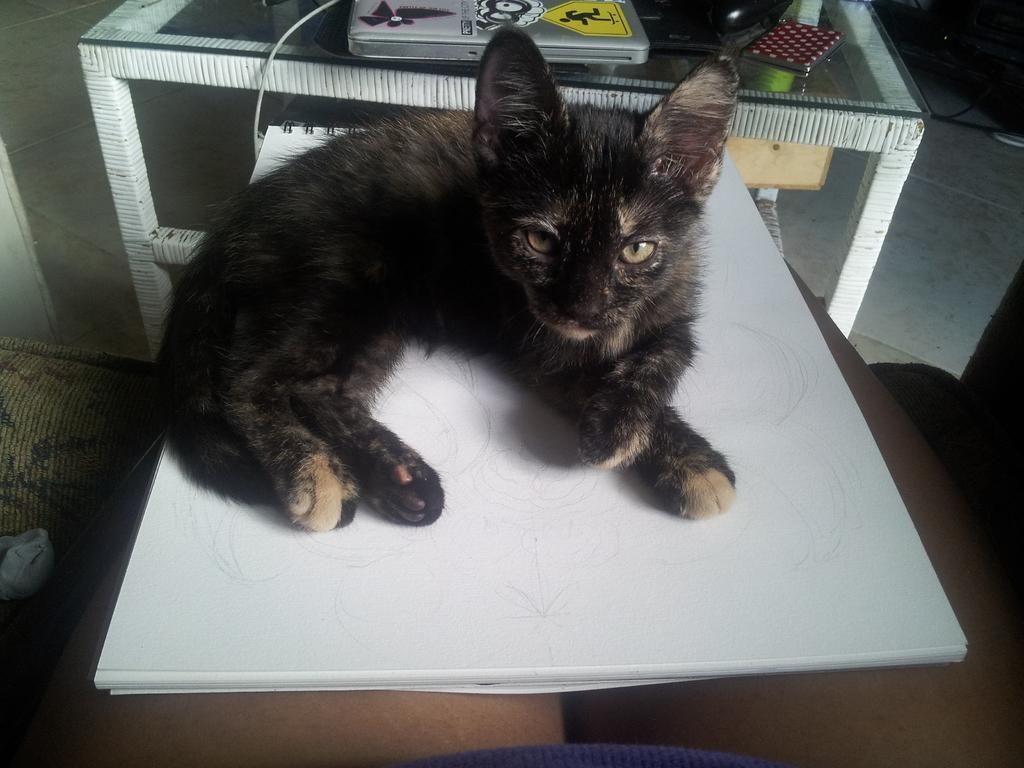What type of animal is in the image? There is a black cat in the image. Where is the cat located? The cat is sitting on a table. What else can be seen on the table? There is a box on the table. What is on top of the box? There is a book on the box. How many birds are flying over the cat in the image? There are no birds present in the image. Are there any boats visible in the image? There are no boats present in the image. 